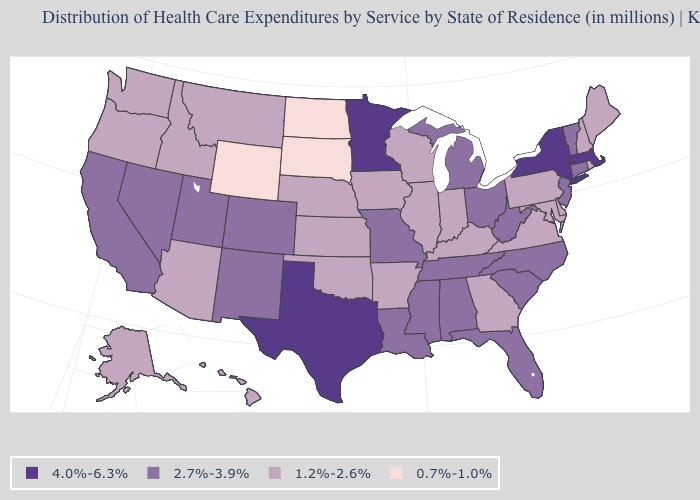Does South Dakota have the lowest value in the USA?
Short answer required. Yes. What is the value of Georgia?
Give a very brief answer. 1.2%-2.6%. Is the legend a continuous bar?
Write a very short answer. No. What is the value of Colorado?
Quick response, please. 2.7%-3.9%. Name the states that have a value in the range 4.0%-6.3%?
Keep it brief. Massachusetts, Minnesota, New York, Texas. Does the map have missing data?
Quick response, please. No. Which states have the lowest value in the Northeast?
Write a very short answer. Maine, New Hampshire, Pennsylvania, Rhode Island. What is the highest value in the MidWest ?
Answer briefly. 4.0%-6.3%. What is the value of Oklahoma?
Keep it brief. 1.2%-2.6%. What is the highest value in states that border Georgia?
Give a very brief answer. 2.7%-3.9%. What is the highest value in the USA?
Concise answer only. 4.0%-6.3%. What is the lowest value in the Northeast?
Quick response, please. 1.2%-2.6%. Name the states that have a value in the range 0.7%-1.0%?
Quick response, please. North Dakota, South Dakota, Wyoming. What is the value of Connecticut?
Write a very short answer. 2.7%-3.9%. What is the highest value in the West ?
Write a very short answer. 2.7%-3.9%. 